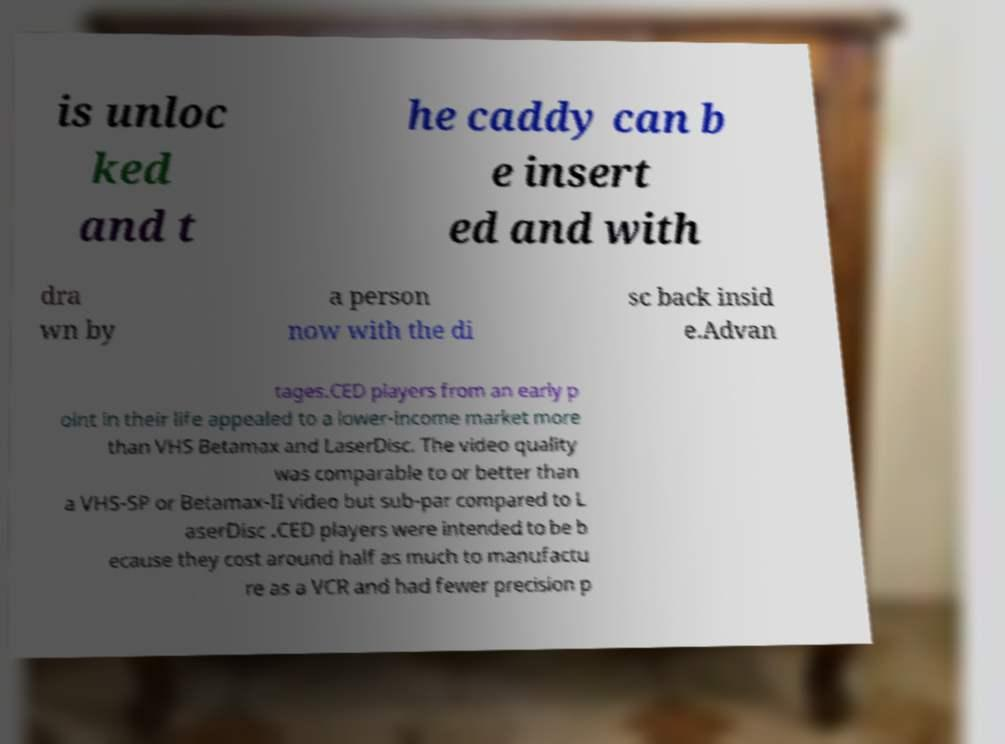Please identify and transcribe the text found in this image. is unloc ked and t he caddy can b e insert ed and with dra wn by a person now with the di sc back insid e.Advan tages.CED players from an early p oint in their life appealed to a lower-income market more than VHS Betamax and LaserDisc. The video quality was comparable to or better than a VHS-SP or Betamax-II video but sub-par compared to L aserDisc .CED players were intended to be b ecause they cost around half as much to manufactu re as a VCR and had fewer precision p 